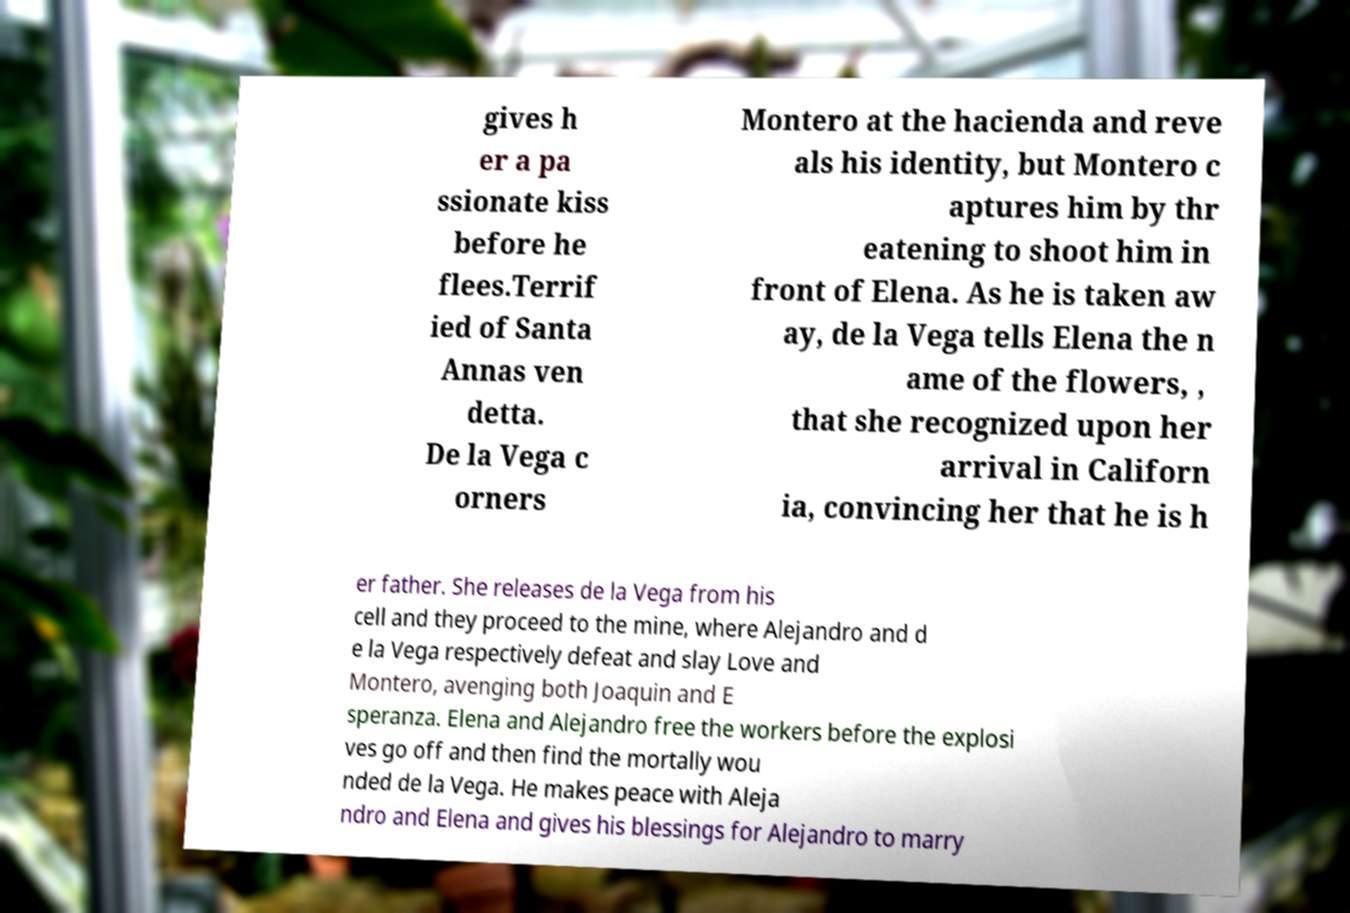Can you read and provide the text displayed in the image?This photo seems to have some interesting text. Can you extract and type it out for me? gives h er a pa ssionate kiss before he flees.Terrif ied of Santa Annas ven detta. De la Vega c orners Montero at the hacienda and reve als his identity, but Montero c aptures him by thr eatening to shoot him in front of Elena. As he is taken aw ay, de la Vega tells Elena the n ame of the flowers, , that she recognized upon her arrival in Californ ia, convincing her that he is h er father. She releases de la Vega from his cell and they proceed to the mine, where Alejandro and d e la Vega respectively defeat and slay Love and Montero, avenging both Joaquin and E speranza. Elena and Alejandro free the workers before the explosi ves go off and then find the mortally wou nded de la Vega. He makes peace with Aleja ndro and Elena and gives his blessings for Alejandro to marry 